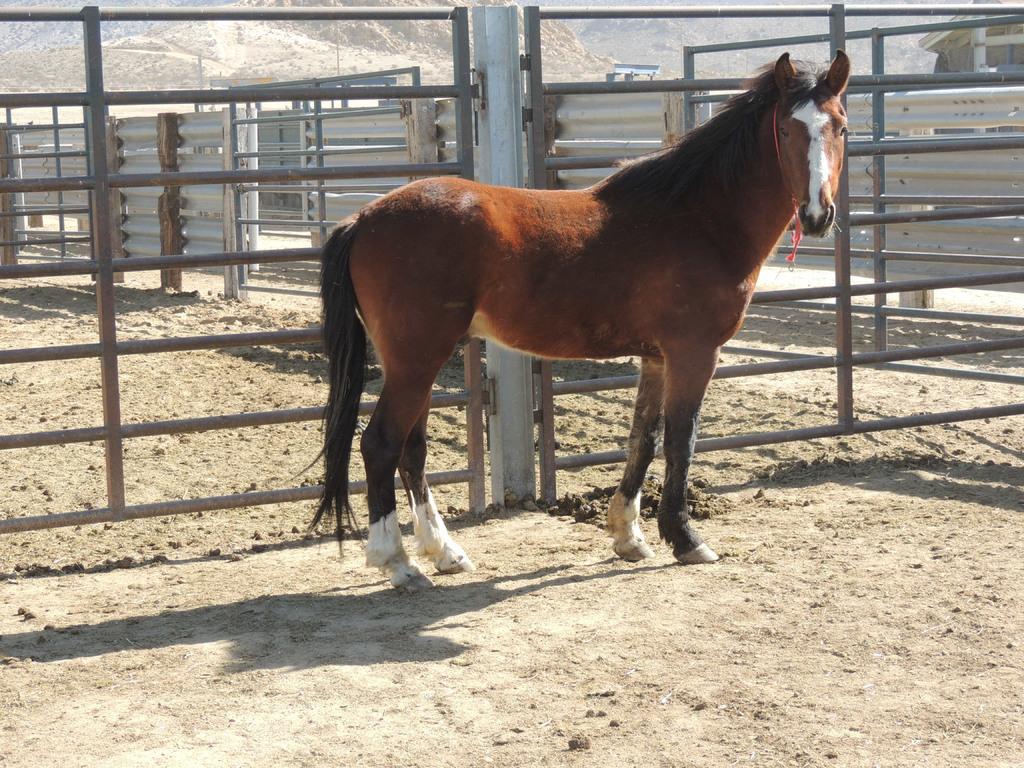Describe this image in one or two sentences. In this image I can see there is a brown color horse in the middle and there are iron grills in the middle of an image. At the bottom it is the sand. 